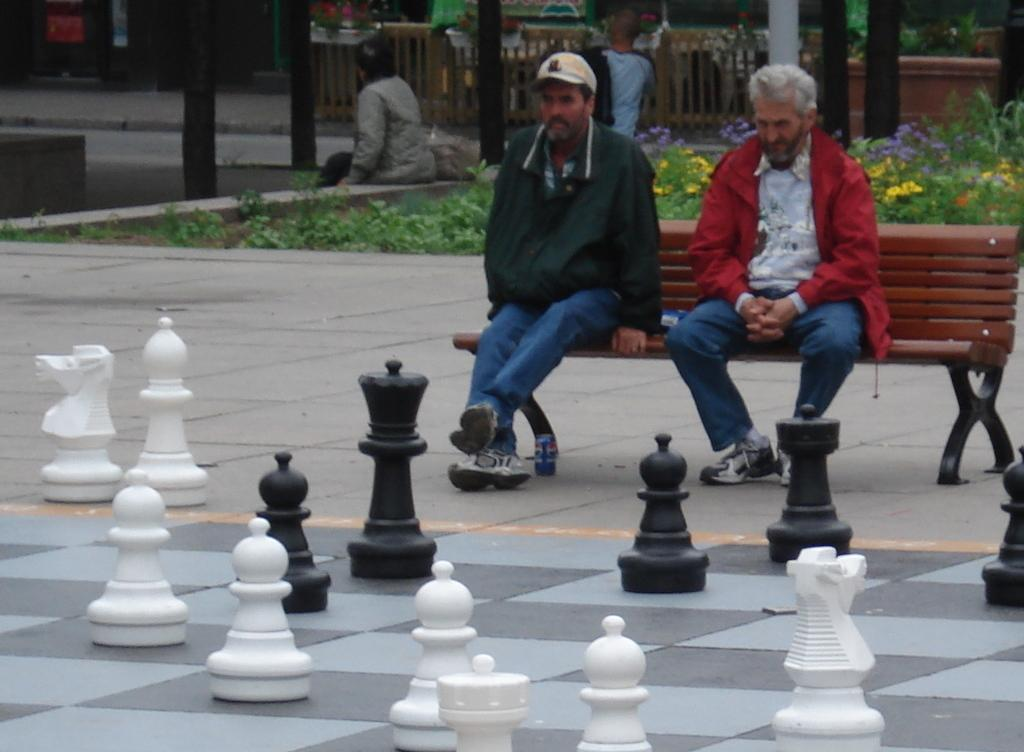How many people are in the image? There are people in the image, specifically two people sitting on a bench. What are the people on the bench doing? The two people on the bench are likely playing chess, as there are chess pieces on the ground. What can be seen in the background of the image? There are plants, a fence, and poles visible in the image. What other objects are present in the image? There are other objects present in the image, but their specific nature is not mentioned in the provided facts. What type of pear is being used as a chess piece in the image? There is no pear present in the image, as the chess pieces are not described in detail. 